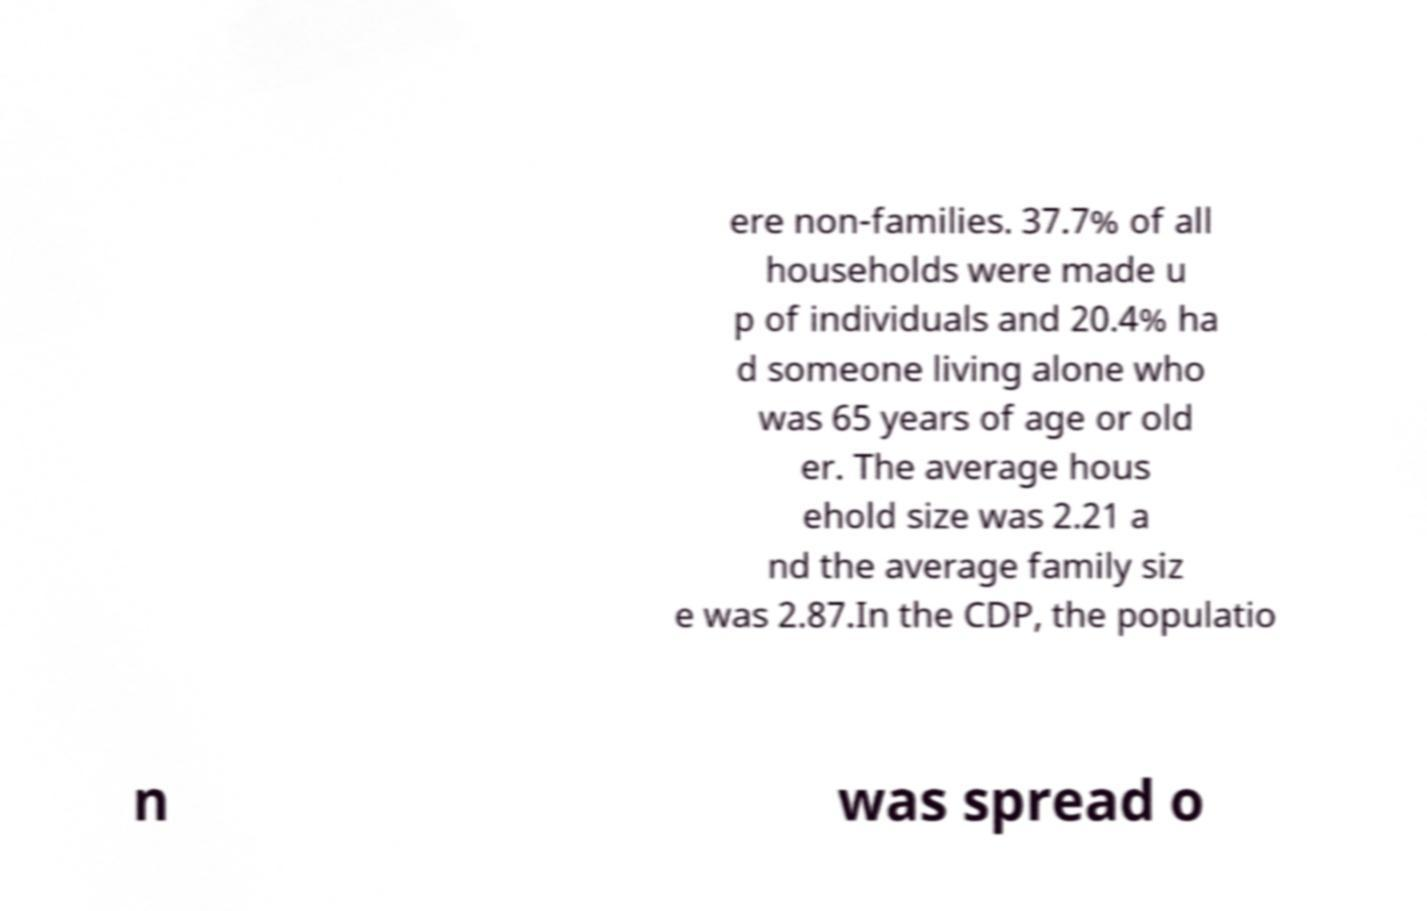Can you accurately transcribe the text from the provided image for me? ere non-families. 37.7% of all households were made u p of individuals and 20.4% ha d someone living alone who was 65 years of age or old er. The average hous ehold size was 2.21 a nd the average family siz e was 2.87.In the CDP, the populatio n was spread o 